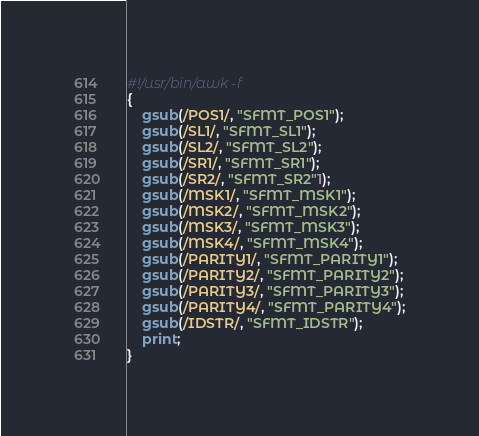<code> <loc_0><loc_0><loc_500><loc_500><_Awk_>#!/usr/bin/awk -f
{
    gsub(/POS1/, "SFMT_POS1");
    gsub(/SL1/, "SFMT_SL1");
    gsub(/SL2/, "SFMT_SL2");
    gsub(/SR1/, "SFMT_SR1");
    gsub(/SR2/, "SFMT_SR2"1);
    gsub(/MSK1/, "SFMT_MSK1");
    gsub(/MSK2/, "SFMT_MSK2");
    gsub(/MSK3/, "SFMT_MSK3");
    gsub(/MSK4/, "SFMT_MSK4");
    gsub(/PARITY1/, "SFMT_PARITY1");
    gsub(/PARITY2/, "SFMT_PARITY2");
    gsub(/PARITY3/, "SFMT_PARITY3");
    gsub(/PARITY4/, "SFMT_PARITY4");
    gsub(/IDSTR/, "SFMT_IDSTR");
    print;
}</code> 